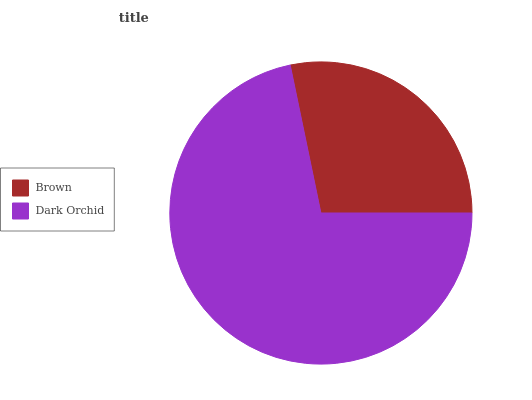Is Brown the minimum?
Answer yes or no. Yes. Is Dark Orchid the maximum?
Answer yes or no. Yes. Is Dark Orchid the minimum?
Answer yes or no. No. Is Dark Orchid greater than Brown?
Answer yes or no. Yes. Is Brown less than Dark Orchid?
Answer yes or no. Yes. Is Brown greater than Dark Orchid?
Answer yes or no. No. Is Dark Orchid less than Brown?
Answer yes or no. No. Is Dark Orchid the high median?
Answer yes or no. Yes. Is Brown the low median?
Answer yes or no. Yes. Is Brown the high median?
Answer yes or no. No. Is Dark Orchid the low median?
Answer yes or no. No. 